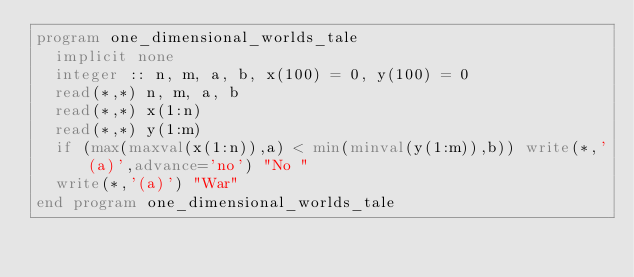Convert code to text. <code><loc_0><loc_0><loc_500><loc_500><_FORTRAN_>program one_dimensional_worlds_tale
  implicit none
  integer :: n, m, a, b, x(100) = 0, y(100) = 0
  read(*,*) n, m, a, b
  read(*,*) x(1:n)
  read(*,*) y(1:m)
  if (max(maxval(x(1:n)),a) < min(minval(y(1:m)),b)) write(*,'(a)',advance='no') "No "
  write(*,'(a)') "War"
end program one_dimensional_worlds_tale</code> 